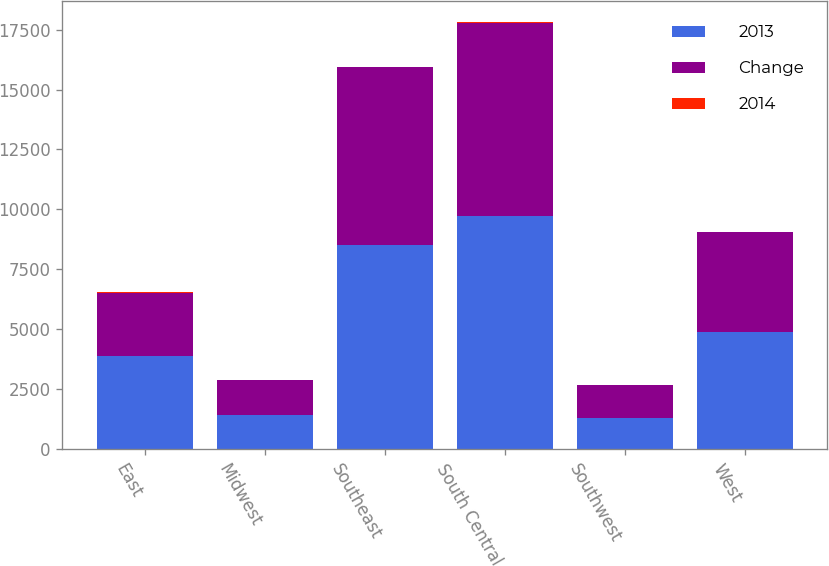<chart> <loc_0><loc_0><loc_500><loc_500><stacked_bar_chart><ecel><fcel>East<fcel>Midwest<fcel>Southeast<fcel>South Central<fcel>Southwest<fcel>West<nl><fcel>2013<fcel>3867<fcel>1413<fcel>8529<fcel>9707<fcel>1298<fcel>4895<nl><fcel>Change<fcel>2624<fcel>1480<fcel>7408<fcel>8074<fcel>1381<fcel>4153<nl><fcel>2014<fcel>47<fcel>5<fcel>15<fcel>20<fcel>6<fcel>18<nl></chart> 